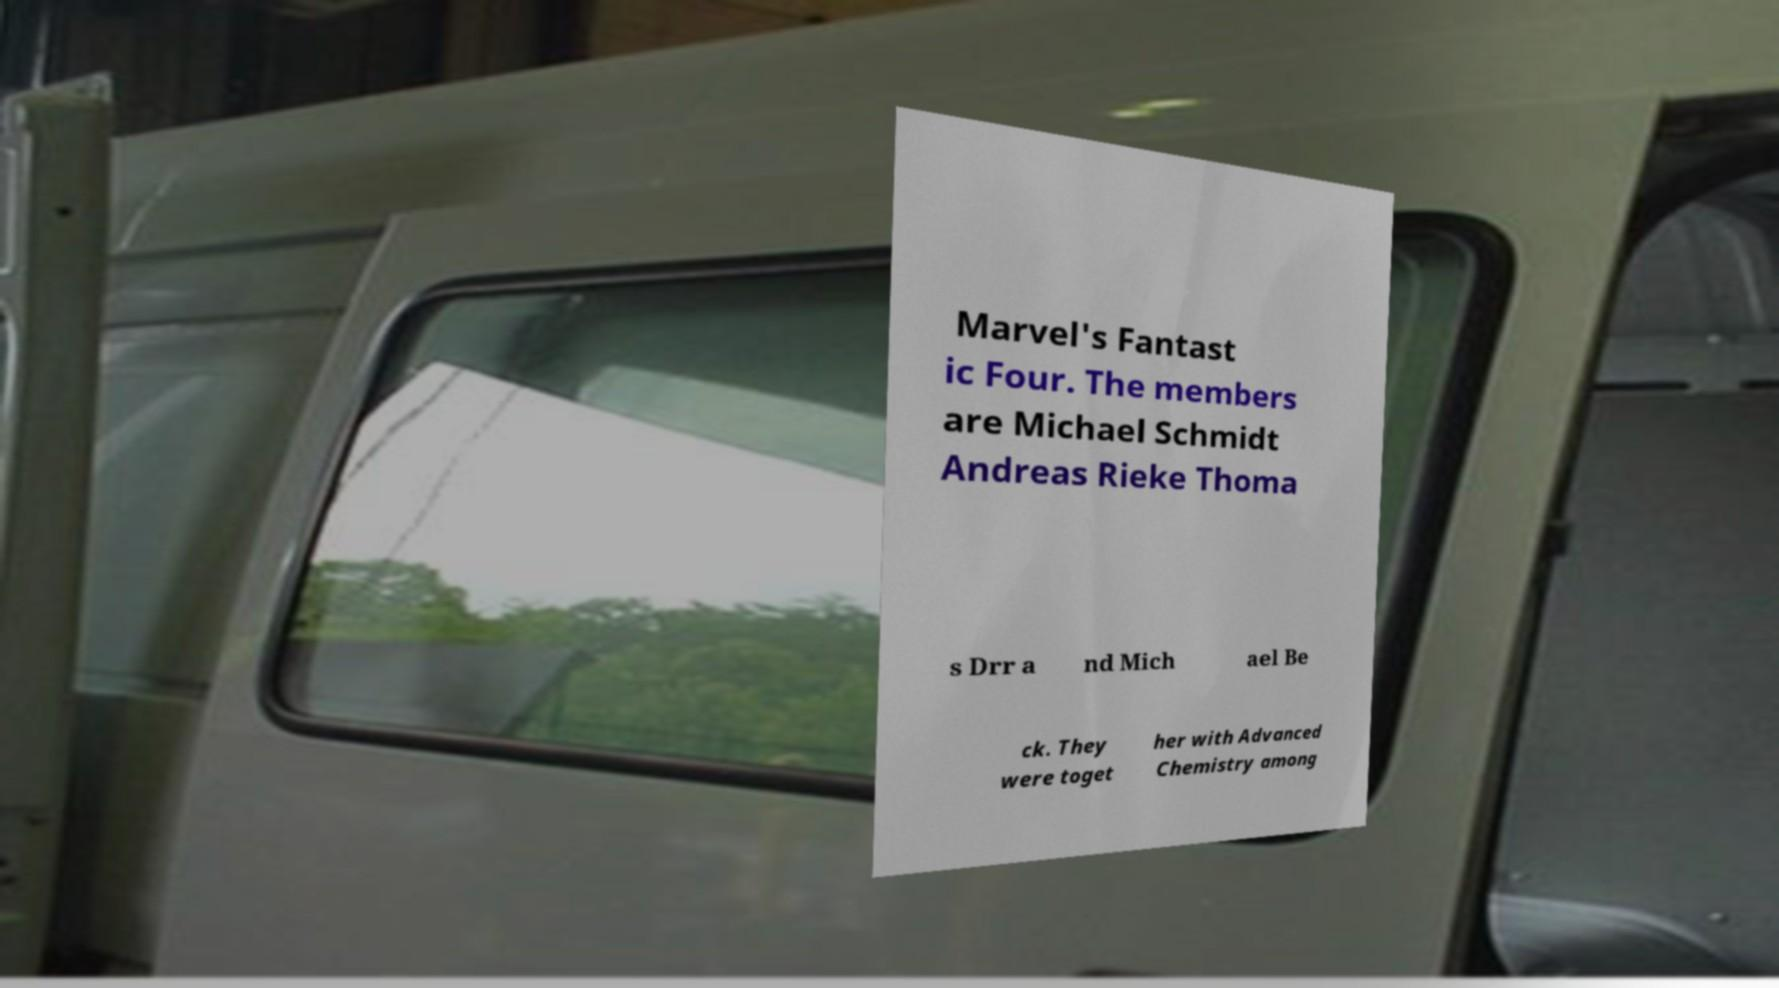Can you accurately transcribe the text from the provided image for me? Marvel's Fantast ic Four. The members are Michael Schmidt Andreas Rieke Thoma s Drr a nd Mich ael Be ck. They were toget her with Advanced Chemistry among 